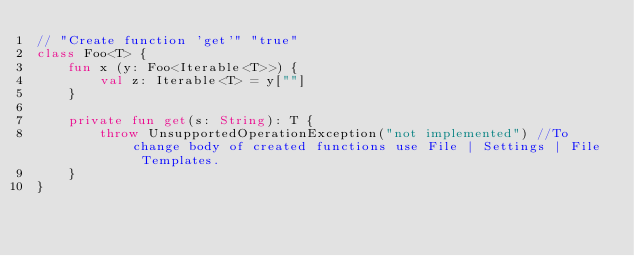Convert code to text. <code><loc_0><loc_0><loc_500><loc_500><_Kotlin_>// "Create function 'get'" "true"
class Foo<T> {
    fun x (y: Foo<Iterable<T>>) {
        val z: Iterable<T> = y[""]
    }

    private fun get(s: String): T {
        throw UnsupportedOperationException("not implemented") //To change body of created functions use File | Settings | File Templates.
    }
}
</code> 